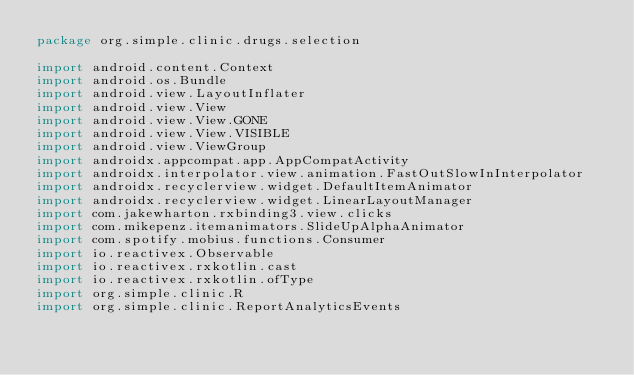<code> <loc_0><loc_0><loc_500><loc_500><_Kotlin_>package org.simple.clinic.drugs.selection

import android.content.Context
import android.os.Bundle
import android.view.LayoutInflater
import android.view.View
import android.view.View.GONE
import android.view.View.VISIBLE
import android.view.ViewGroup
import androidx.appcompat.app.AppCompatActivity
import androidx.interpolator.view.animation.FastOutSlowInInterpolator
import androidx.recyclerview.widget.DefaultItemAnimator
import androidx.recyclerview.widget.LinearLayoutManager
import com.jakewharton.rxbinding3.view.clicks
import com.mikepenz.itemanimators.SlideUpAlphaAnimator
import com.spotify.mobius.functions.Consumer
import io.reactivex.Observable
import io.reactivex.rxkotlin.cast
import io.reactivex.rxkotlin.ofType
import org.simple.clinic.R
import org.simple.clinic.ReportAnalyticsEvents</code> 